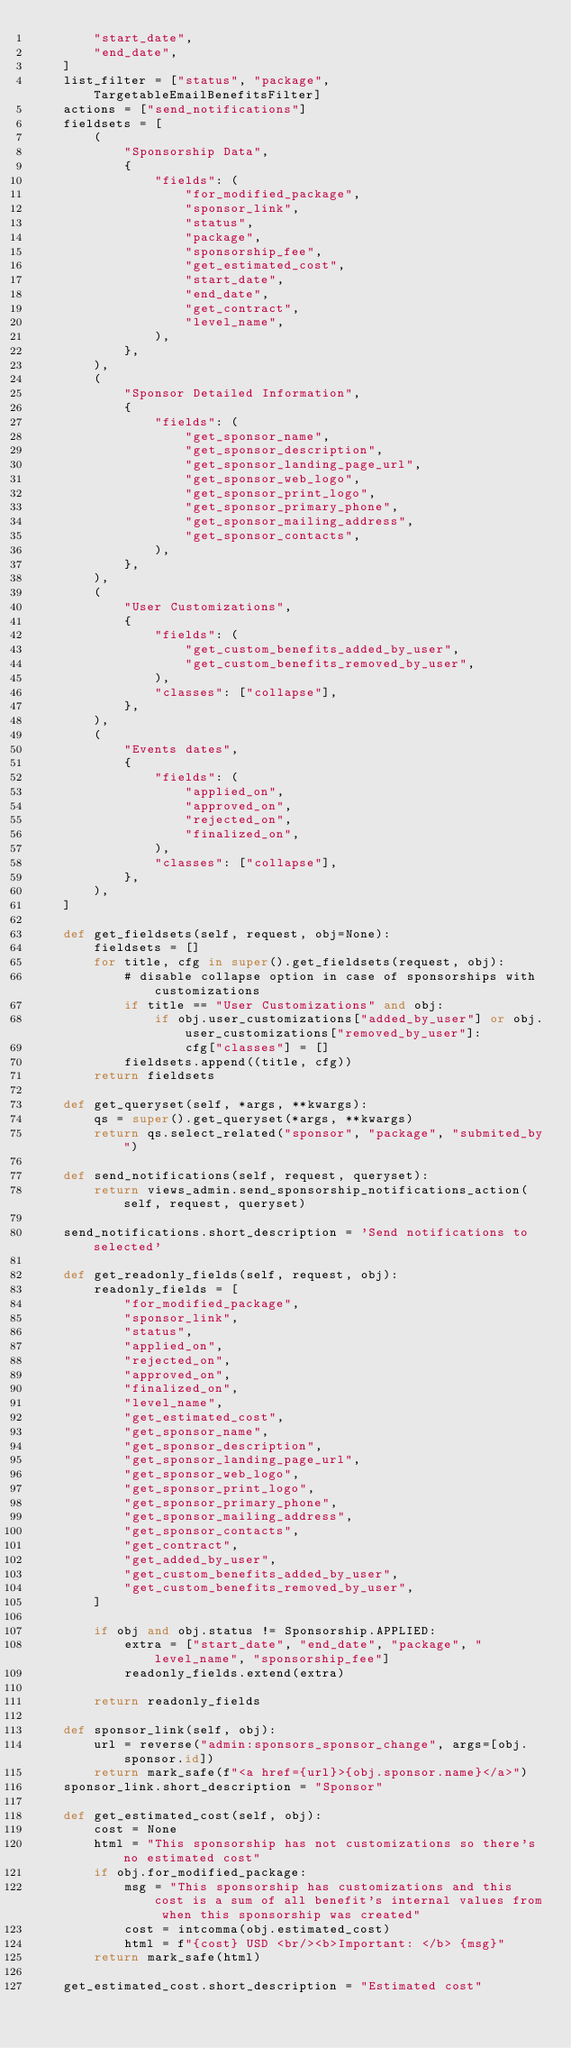Convert code to text. <code><loc_0><loc_0><loc_500><loc_500><_Python_>        "start_date",
        "end_date",
    ]
    list_filter = ["status", "package", TargetableEmailBenefitsFilter]
    actions = ["send_notifications"]
    fieldsets = [
        (
            "Sponsorship Data",
            {
                "fields": (
                    "for_modified_package",
                    "sponsor_link",
                    "status",
                    "package",
                    "sponsorship_fee",
                    "get_estimated_cost",
                    "start_date",
                    "end_date",
                    "get_contract",
                    "level_name",
                ),
            },
        ),
        (
            "Sponsor Detailed Information",
            {
                "fields": (
                    "get_sponsor_name",
                    "get_sponsor_description",
                    "get_sponsor_landing_page_url",
                    "get_sponsor_web_logo",
                    "get_sponsor_print_logo",
                    "get_sponsor_primary_phone",
                    "get_sponsor_mailing_address",
                    "get_sponsor_contacts",
                ),
            },
        ),
        (
            "User Customizations",
            {
                "fields": (
                    "get_custom_benefits_added_by_user",
                    "get_custom_benefits_removed_by_user",
                ),
                "classes": ["collapse"],
            },
        ),
        (
            "Events dates",
            {
                "fields": (
                    "applied_on",
                    "approved_on",
                    "rejected_on",
                    "finalized_on",
                ),
                "classes": ["collapse"],
            },
        ),
    ]

    def get_fieldsets(self, request, obj=None):
        fieldsets = []
        for title, cfg in super().get_fieldsets(request, obj):
            # disable collapse option in case of sponsorships with customizations
            if title == "User Customizations" and obj:
                if obj.user_customizations["added_by_user"] or obj.user_customizations["removed_by_user"]:
                    cfg["classes"] = []
            fieldsets.append((title, cfg))
        return fieldsets

    def get_queryset(self, *args, **kwargs):
        qs = super().get_queryset(*args, **kwargs)
        return qs.select_related("sponsor", "package", "submited_by")

    def send_notifications(self, request, queryset):
        return views_admin.send_sponsorship_notifications_action(self, request, queryset)

    send_notifications.short_description = 'Send notifications to selected'

    def get_readonly_fields(self, request, obj):
        readonly_fields = [
            "for_modified_package",
            "sponsor_link",
            "status",
            "applied_on",
            "rejected_on",
            "approved_on",
            "finalized_on",
            "level_name",
            "get_estimated_cost",
            "get_sponsor_name",
            "get_sponsor_description",
            "get_sponsor_landing_page_url",
            "get_sponsor_web_logo",
            "get_sponsor_print_logo",
            "get_sponsor_primary_phone",
            "get_sponsor_mailing_address",
            "get_sponsor_contacts",
            "get_contract",
            "get_added_by_user",
            "get_custom_benefits_added_by_user",
            "get_custom_benefits_removed_by_user",
        ]

        if obj and obj.status != Sponsorship.APPLIED:
            extra = ["start_date", "end_date", "package", "level_name", "sponsorship_fee"]
            readonly_fields.extend(extra)

        return readonly_fields

    def sponsor_link(self, obj):
        url = reverse("admin:sponsors_sponsor_change", args=[obj.sponsor.id])
        return mark_safe(f"<a href={url}>{obj.sponsor.name}</a>")
    sponsor_link.short_description = "Sponsor"

    def get_estimated_cost(self, obj):
        cost = None
        html = "This sponsorship has not customizations so there's no estimated cost"
        if obj.for_modified_package:
            msg = "This sponsorship has customizations and this cost is a sum of all benefit's internal values from when this sponsorship was created"
            cost = intcomma(obj.estimated_cost)
            html = f"{cost} USD <br/><b>Important: </b> {msg}"
        return mark_safe(html)

    get_estimated_cost.short_description = "Estimated cost"
</code> 